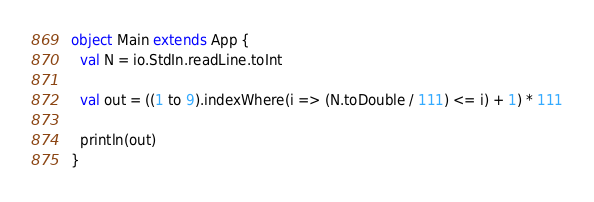<code> <loc_0><loc_0><loc_500><loc_500><_Scala_>object Main extends App {
  val N = io.StdIn.readLine.toInt

  val out = ((1 to 9).indexWhere(i => (N.toDouble / 111) <= i) + 1) * 111

  println(out)
}</code> 